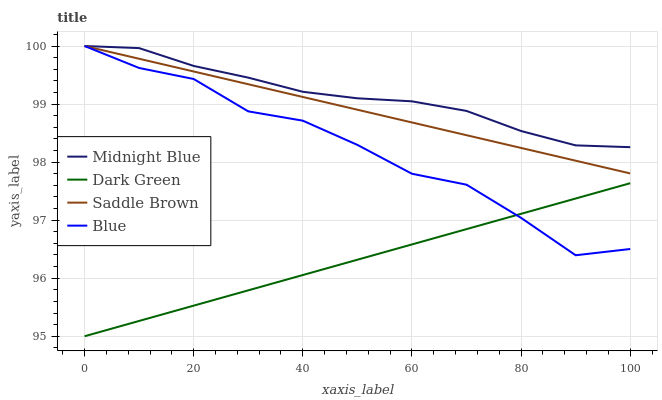Does Dark Green have the minimum area under the curve?
Answer yes or no. Yes. Does Midnight Blue have the maximum area under the curve?
Answer yes or no. Yes. Does Blue have the minimum area under the curve?
Answer yes or no. No. Does Blue have the maximum area under the curve?
Answer yes or no. No. Is Dark Green the smoothest?
Answer yes or no. Yes. Is Blue the roughest?
Answer yes or no. Yes. Is Midnight Blue the smoothest?
Answer yes or no. No. Is Midnight Blue the roughest?
Answer yes or no. No. Does Dark Green have the lowest value?
Answer yes or no. Yes. Does Blue have the lowest value?
Answer yes or no. No. Does Midnight Blue have the highest value?
Answer yes or no. Yes. Does Dark Green have the highest value?
Answer yes or no. No. Is Dark Green less than Saddle Brown?
Answer yes or no. Yes. Is Saddle Brown greater than Dark Green?
Answer yes or no. Yes. Does Blue intersect Dark Green?
Answer yes or no. Yes. Is Blue less than Dark Green?
Answer yes or no. No. Is Blue greater than Dark Green?
Answer yes or no. No. Does Dark Green intersect Saddle Brown?
Answer yes or no. No. 